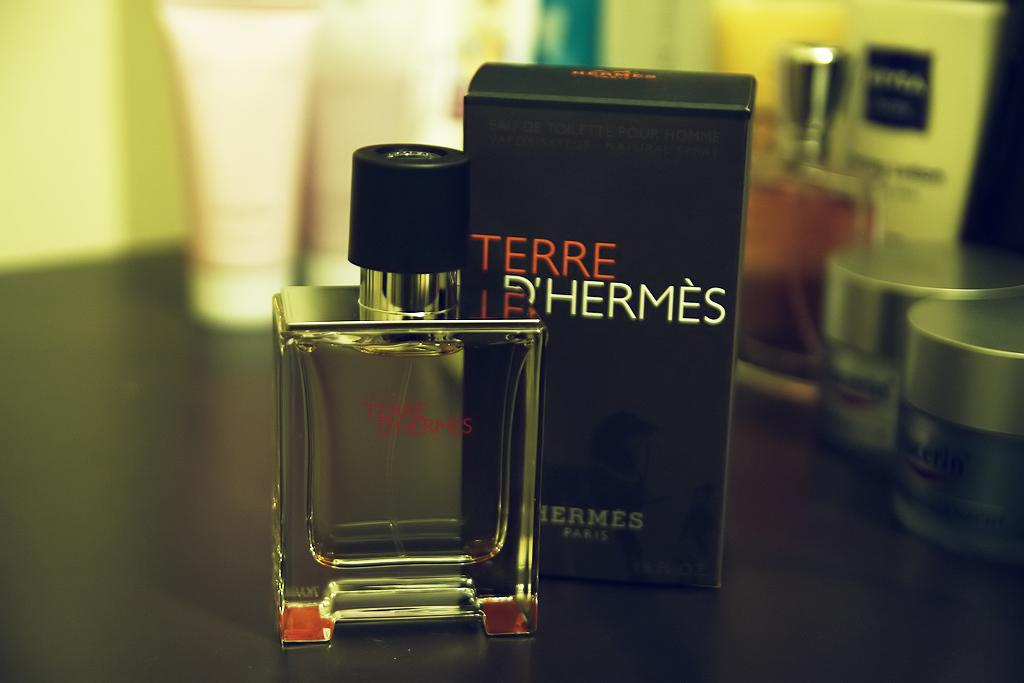<image>
Relay a brief, clear account of the picture shown. A bottle of Terre D'Hermes cologne sits next to the product box. 